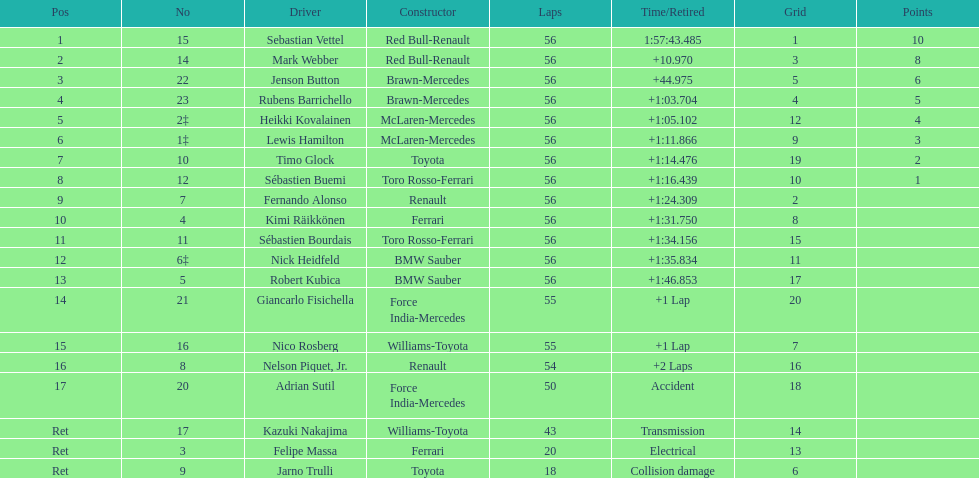What is the total number of drivers on the list? 20. 